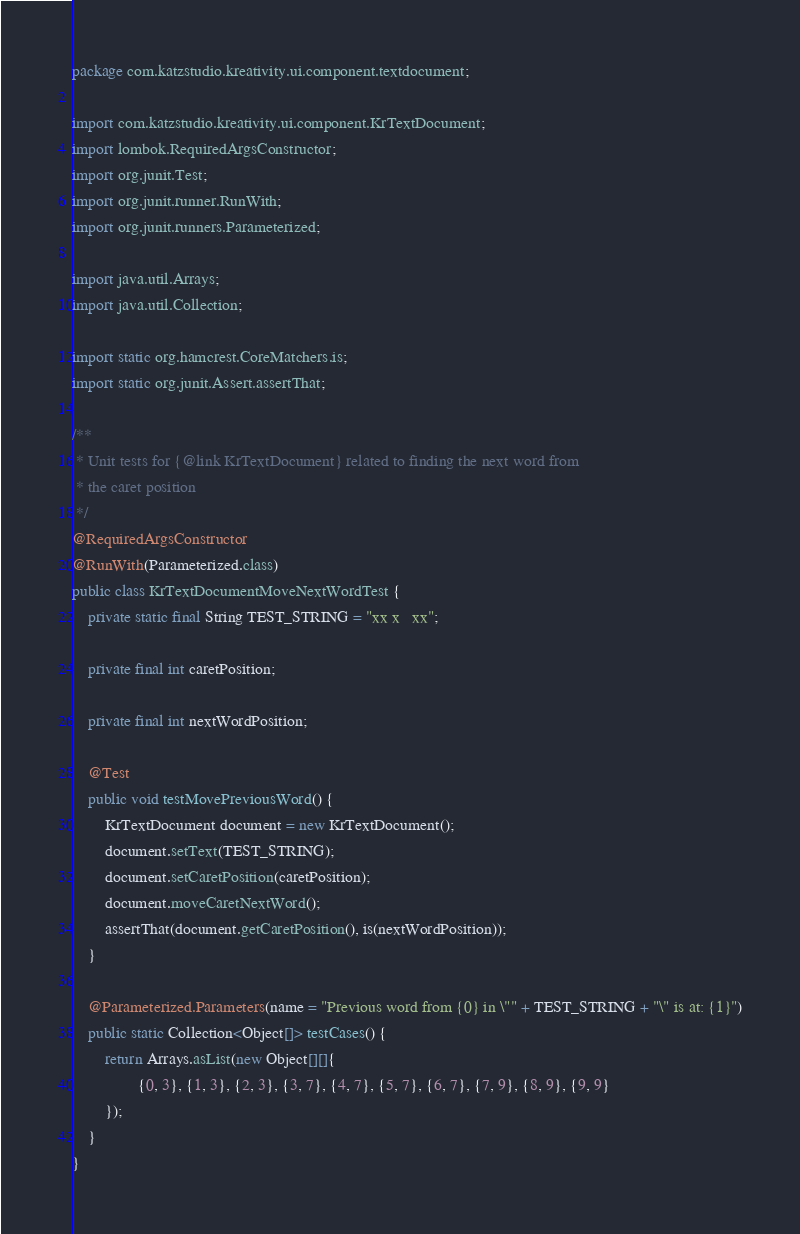<code> <loc_0><loc_0><loc_500><loc_500><_Java_>package com.katzstudio.kreativity.ui.component.textdocument;

import com.katzstudio.kreativity.ui.component.KrTextDocument;
import lombok.RequiredArgsConstructor;
import org.junit.Test;
import org.junit.runner.RunWith;
import org.junit.runners.Parameterized;

import java.util.Arrays;
import java.util.Collection;

import static org.hamcrest.CoreMatchers.is;
import static org.junit.Assert.assertThat;

/**
 * Unit tests for {@link KrTextDocument} related to finding the next word from
 * the caret position
 */
@RequiredArgsConstructor
@RunWith(Parameterized.class)
public class KrTextDocumentMoveNextWordTest {
    private static final String TEST_STRING = "xx x   xx";

    private final int caretPosition;

    private final int nextWordPosition;

    @Test
    public void testMovePreviousWord() {
        KrTextDocument document = new KrTextDocument();
        document.setText(TEST_STRING);
        document.setCaretPosition(caretPosition);
        document.moveCaretNextWord();
        assertThat(document.getCaretPosition(), is(nextWordPosition));
    }

    @Parameterized.Parameters(name = "Previous word from {0} in \"" + TEST_STRING + "\" is at: {1}")
    public static Collection<Object[]> testCases() {
        return Arrays.asList(new Object[][]{
                {0, 3}, {1, 3}, {2, 3}, {3, 7}, {4, 7}, {5, 7}, {6, 7}, {7, 9}, {8, 9}, {9, 9}
        });
    }
}
</code> 